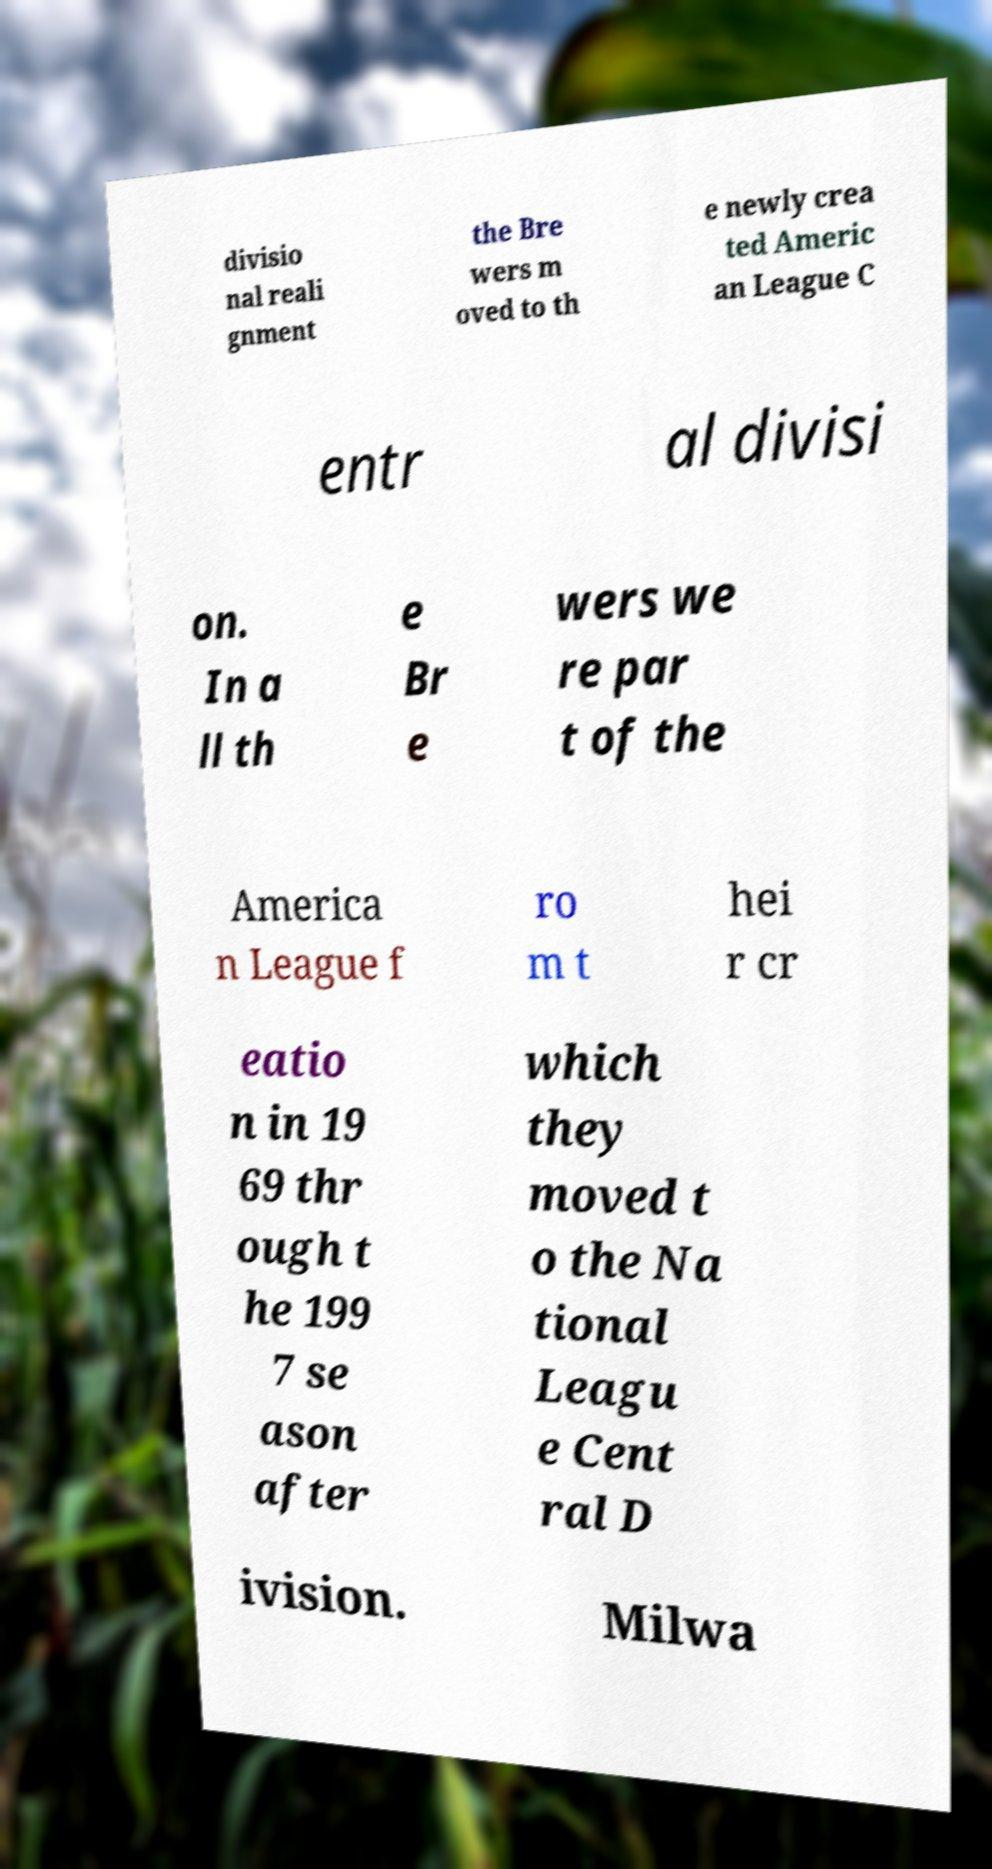Please identify and transcribe the text found in this image. divisio nal reali gnment the Bre wers m oved to th e newly crea ted Americ an League C entr al divisi on. In a ll th e Br e wers we re par t of the America n League f ro m t hei r cr eatio n in 19 69 thr ough t he 199 7 se ason after which they moved t o the Na tional Leagu e Cent ral D ivision. Milwa 